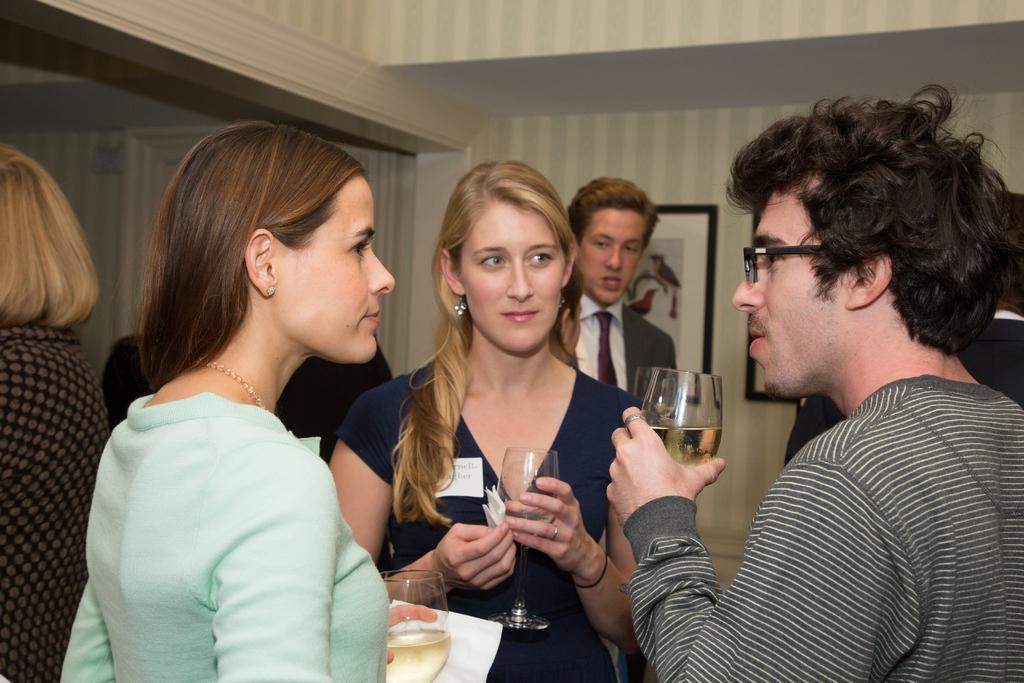How would you summarize this image in a sentence or two? In this image there are some persons standing and some of them are holding glasses and tissues, and in the background there are some photo frames on the wall. 